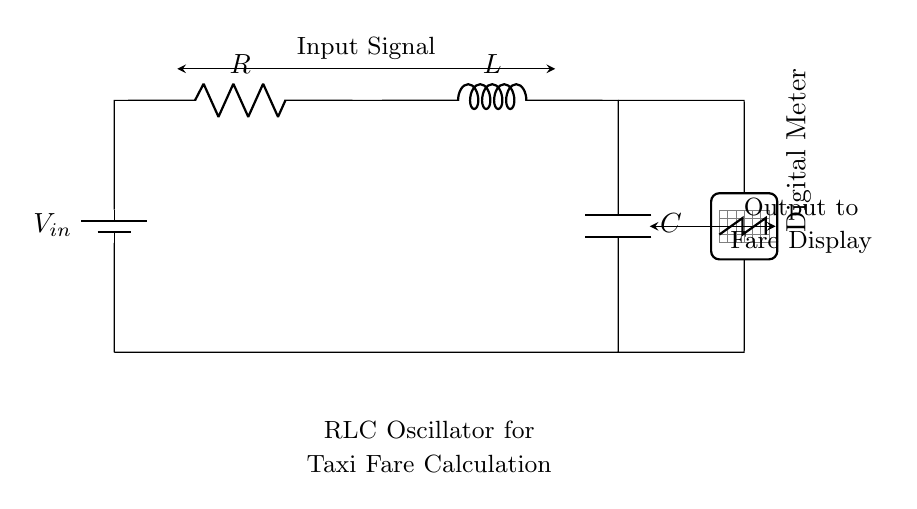What type of components are used in this circuit? The circuit contains a resistor, inductor, and capacitor, which are the fundamental components used in an RLC oscillator.
Answer: Resistor, inductor, capacitor What is the purpose of the digital meter in this circuit? The digital meter displays the output signal from the RLC oscillator, which is used for accurate fare calculation in the taxi's meter.
Answer: Fare calculation What is connected to the circuit's input? The input to the circuit is a voltage source, which provides power to the RLC components for operation.
Answer: Voltage source How many components are in series in this circuit? The resistor, inductor, and capacitor are connected in series to form a loop in the circuit, making it three components in series.
Answer: Three What does the output signal represent? The output signal generated by the circuit represents the oscillating voltage that is converted and displayed as the fare amount on the digital meter.
Answer: Oscillating voltage What is the main function of the inductor in this circuit? The inductor in this RLC circuit stores energy in the magnetic field and helps regulate the oscillation frequency of the circuit.
Answer: Energy storage What happens if the resistance is increased in this circuit? Increasing resistance generally leads to decreased oscillation amplitude and can affect the overall stability of the RLC circuit, potentially resulting in under-damped or over-damped behavior.
Answer: Decreased oscillation amplitude 